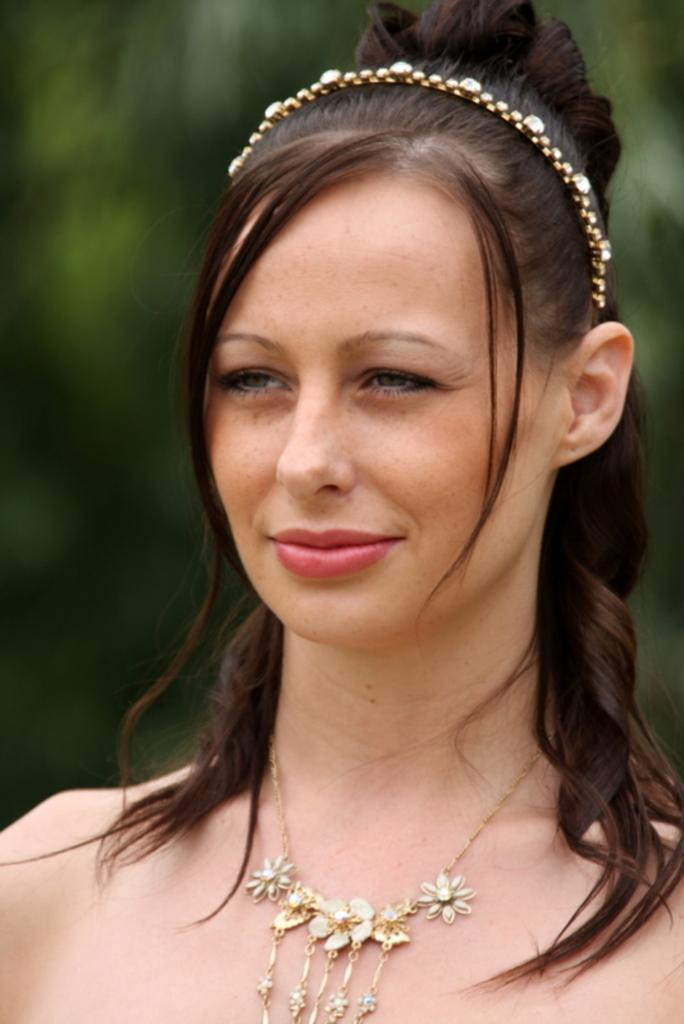Who is present in the image? There is a woman in the image. What can be seen in the background of the image? There are trees in the background of the image. What is the woman's net worth in the image? There is no information about the woman's net worth in the image. How much snow is visible in the image? There is no snow present in the image. 